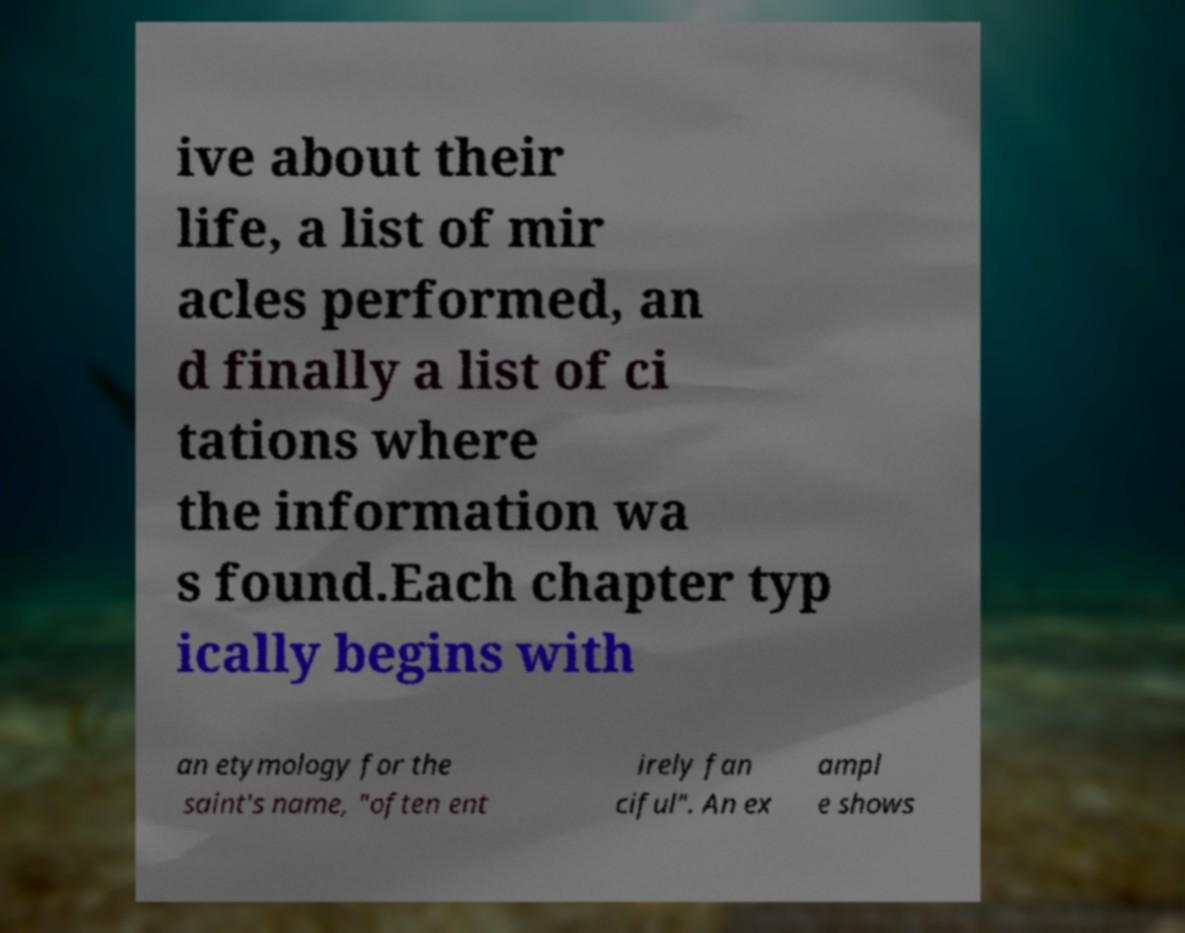Please identify and transcribe the text found in this image. ive about their life, a list of mir acles performed, an d finally a list of ci tations where the information wa s found.Each chapter typ ically begins with an etymology for the saint's name, "often ent irely fan ciful". An ex ampl e shows 